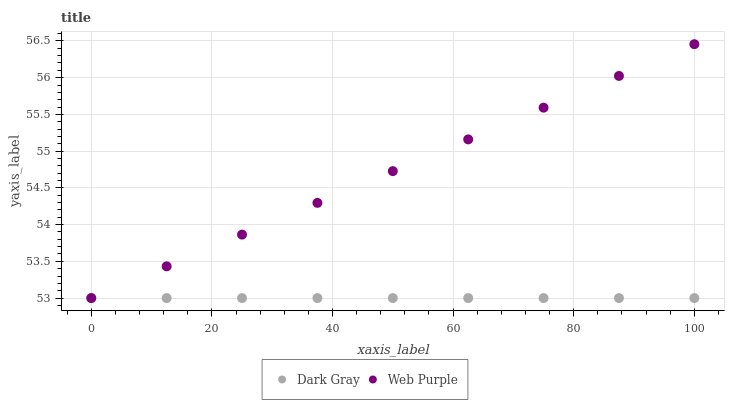Does Dark Gray have the minimum area under the curve?
Answer yes or no. Yes. Does Web Purple have the maximum area under the curve?
Answer yes or no. Yes. Does Web Purple have the minimum area under the curve?
Answer yes or no. No. Is Dark Gray the smoothest?
Answer yes or no. Yes. Is Web Purple the roughest?
Answer yes or no. Yes. Is Web Purple the smoothest?
Answer yes or no. No. Does Dark Gray have the lowest value?
Answer yes or no. Yes. Does Web Purple have the highest value?
Answer yes or no. Yes. Does Web Purple intersect Dark Gray?
Answer yes or no. Yes. Is Web Purple less than Dark Gray?
Answer yes or no. No. Is Web Purple greater than Dark Gray?
Answer yes or no. No. 